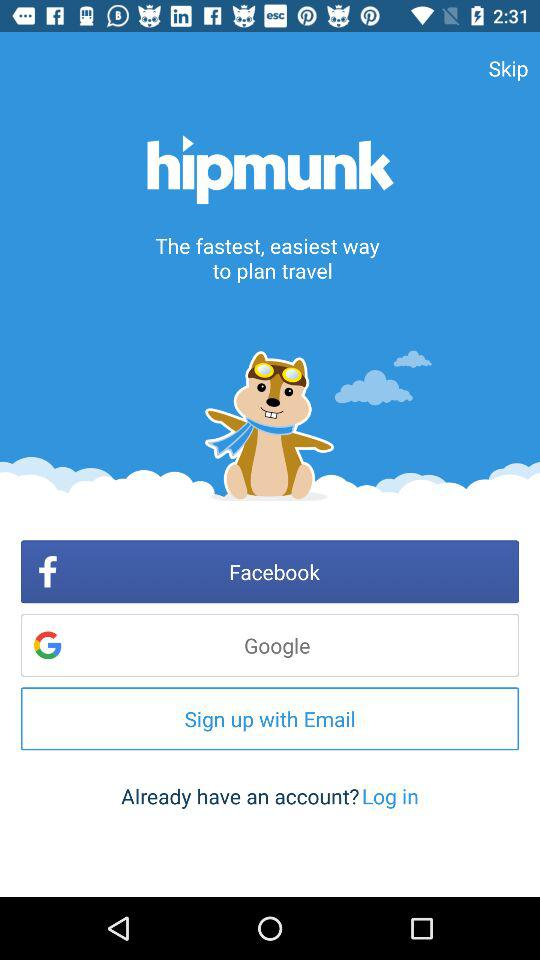What accounts can I use to sign up? You can use "Facebook", "Google" and "Email" accounts. 